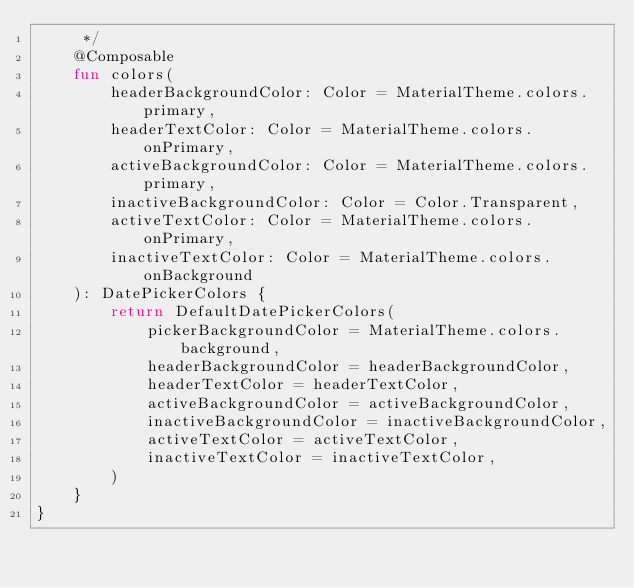<code> <loc_0><loc_0><loc_500><loc_500><_Kotlin_>     */
    @Composable
    fun colors(
        headerBackgroundColor: Color = MaterialTheme.colors.primary,
        headerTextColor: Color = MaterialTheme.colors.onPrimary,
        activeBackgroundColor: Color = MaterialTheme.colors.primary,
        inactiveBackgroundColor: Color = Color.Transparent,
        activeTextColor: Color = MaterialTheme.colors.onPrimary,
        inactiveTextColor: Color = MaterialTheme.colors.onBackground
    ): DatePickerColors {
        return DefaultDatePickerColors(
            pickerBackgroundColor = MaterialTheme.colors.background,
            headerBackgroundColor = headerBackgroundColor,
            headerTextColor = headerTextColor,
            activeBackgroundColor = activeBackgroundColor,
            inactiveBackgroundColor = inactiveBackgroundColor,
            activeTextColor = activeTextColor,
            inactiveTextColor = inactiveTextColor,
        )
    }
}
</code> 